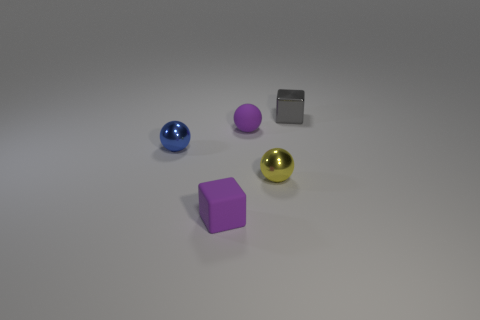What is the shape of the yellow thing that is the same size as the rubber sphere?
Offer a very short reply. Sphere. Is the material of the gray block the same as the blue object?
Make the answer very short. Yes. What number of matte things are large brown things or tiny purple spheres?
Provide a short and direct response. 1. What is the shape of the object that is the same color as the matte block?
Ensure brevity in your answer.  Sphere. Does the tiny cube in front of the gray metallic thing have the same color as the rubber ball?
Your answer should be very brief. Yes. The matte object that is in front of the tiny purple object that is behind the blue thing is what shape?
Give a very brief answer. Cube. How many objects are small matte things that are in front of the metal cube or small things right of the matte block?
Give a very brief answer. 4. There is a small blue object that is made of the same material as the gray block; what is its shape?
Offer a terse response. Sphere. Is there anything else that has the same color as the tiny metal cube?
Offer a terse response. No. There is a yellow thing that is the same shape as the blue thing; what material is it?
Offer a terse response. Metal. 